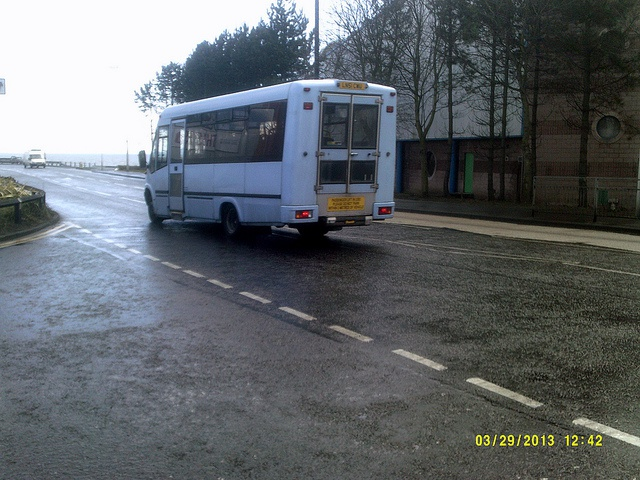Describe the objects in this image and their specific colors. I can see bus in white, black, and gray tones, car in white, darkgray, and gray tones, and car in white, gray, and darkgray tones in this image. 